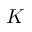Convert formula to latex. <formula><loc_0><loc_0><loc_500><loc_500>K</formula> 